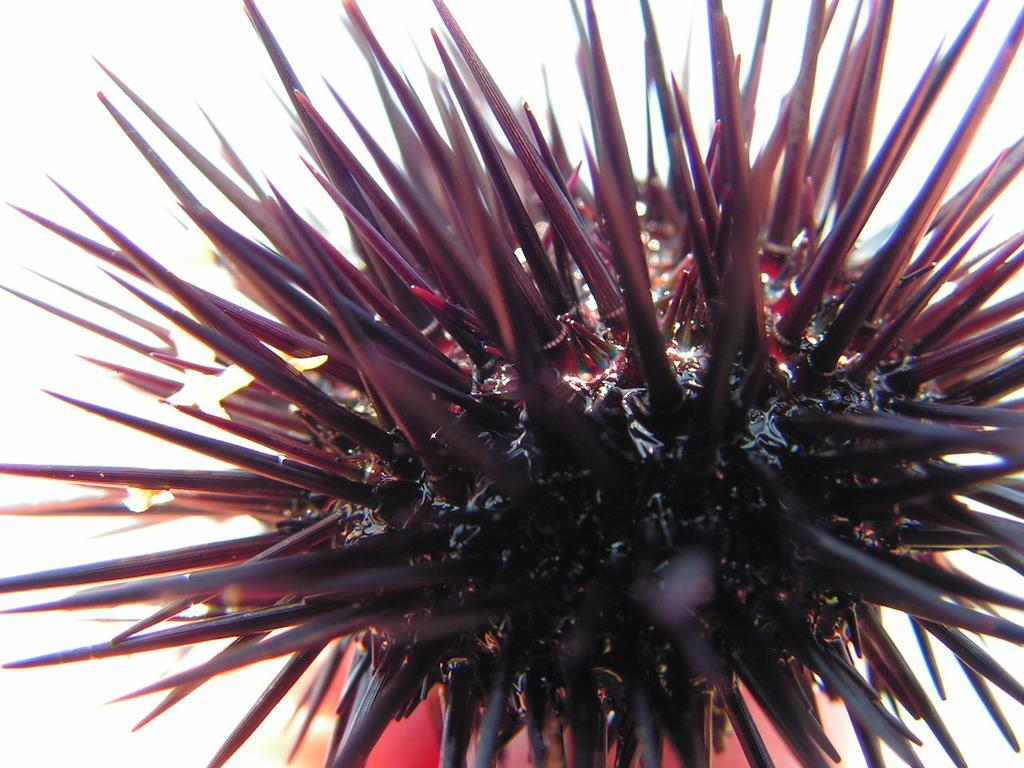What is the color of the main object in the image? The main object in the image is black and maroon colored. What color can be seen in the background of the image? The background of the image has a white color. How many parcels are being delivered in the image? There is no parcel visible in the image. What type of string is tied around the object in the image? There is no string tied around the object in the image. 